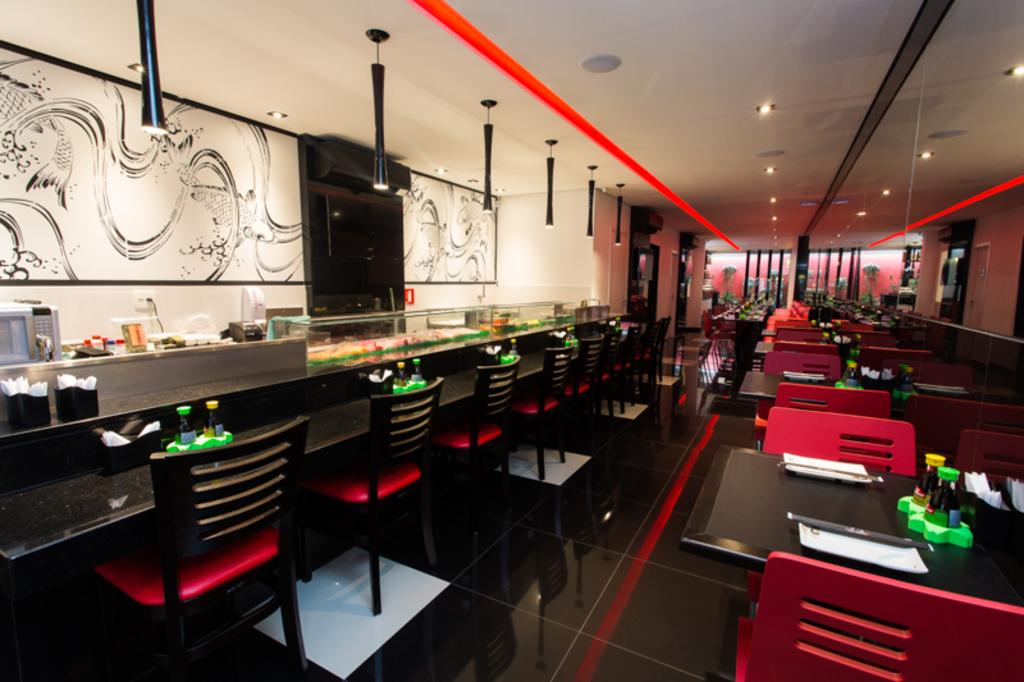What type of furniture can be seen in the image? There are chairs and tables in the image. What is the flooring material in the image? The floor is tiled. Can you describe the wall in the image? There is a designer wall in the image. What type of lighting is present in the image? There are lights in the image. What objects are on the tables in the image? On the tables, there are bottles, tissue papers, an oven, and other things. Can you see any worms crawling on the floor in the image? There are no worms present in the image; the floor is tiled. What type of rock is featured in the image? There is no rock present in the image. 